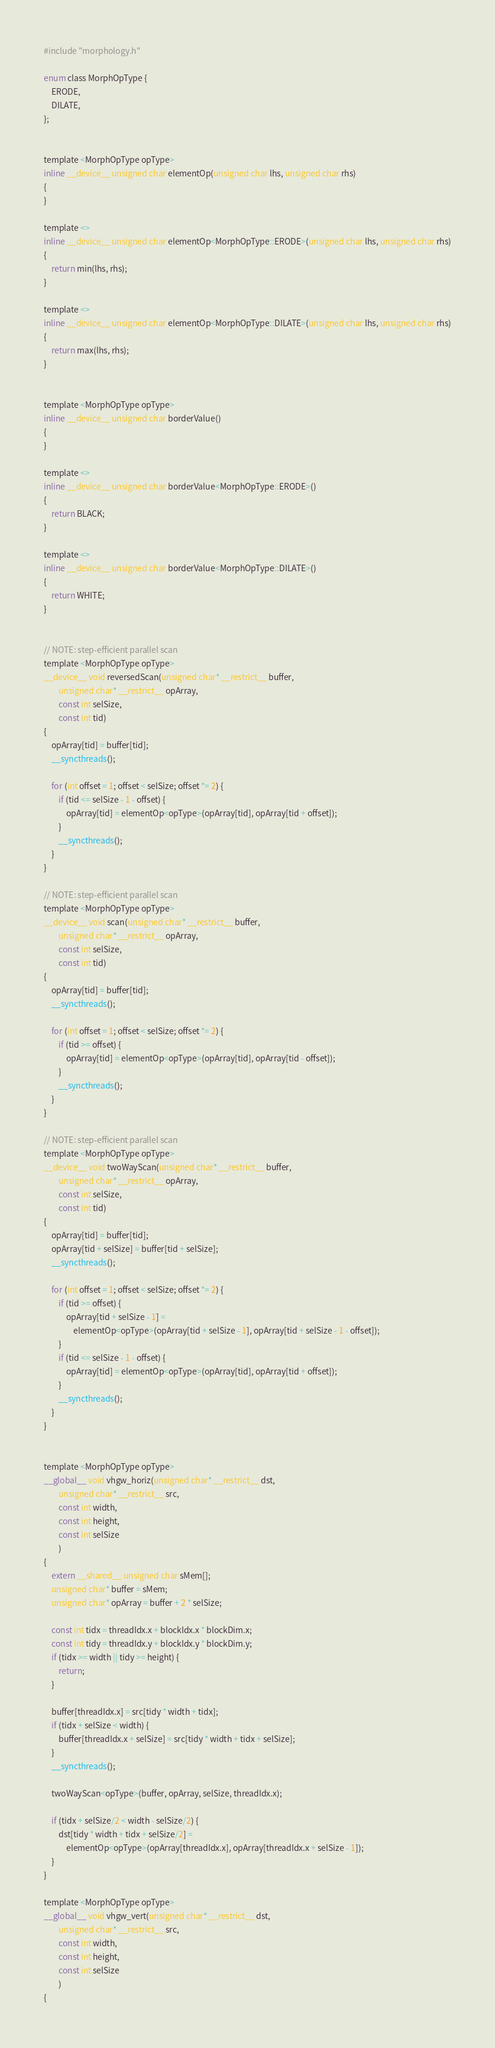<code> <loc_0><loc_0><loc_500><loc_500><_Cuda_>#include "morphology.h"

enum class MorphOpType {
    ERODE,
    DILATE,
};


template <MorphOpType opType>
inline __device__ unsigned char elementOp(unsigned char lhs, unsigned char rhs)
{
}

template <>
inline __device__ unsigned char elementOp<MorphOpType::ERODE>(unsigned char lhs, unsigned char rhs)
{
    return min(lhs, rhs);
}

template <>
inline __device__ unsigned char elementOp<MorphOpType::DILATE>(unsigned char lhs, unsigned char rhs)
{
    return max(lhs, rhs);
}


template <MorphOpType opType>
inline __device__ unsigned char borderValue()
{
}

template <>
inline __device__ unsigned char borderValue<MorphOpType::ERODE>()
{
    return BLACK;
}

template <>
inline __device__ unsigned char borderValue<MorphOpType::DILATE>()
{
    return WHITE;
}


// NOTE: step-efficient parallel scan
template <MorphOpType opType>
__device__ void reversedScan(unsigned char* __restrict__ buffer,
        unsigned char* __restrict__ opArray,
        const int selSize,
        const int tid)
{
    opArray[tid] = buffer[tid];
    __syncthreads();

    for (int offset = 1; offset < selSize; offset *= 2) {
        if (tid <= selSize - 1 - offset) {
            opArray[tid] = elementOp<opType>(opArray[tid], opArray[tid + offset]);
        }
        __syncthreads();
    }
}

// NOTE: step-efficient parallel scan
template <MorphOpType opType>
__device__ void scan(unsigned char* __restrict__ buffer,
        unsigned char* __restrict__ opArray,
        const int selSize,
        const int tid)
{
    opArray[tid] = buffer[tid];
    __syncthreads();

    for (int offset = 1; offset < selSize; offset *= 2) {
        if (tid >= offset) {
            opArray[tid] = elementOp<opType>(opArray[tid], opArray[tid - offset]);
        }
        __syncthreads();
    }
}

// NOTE: step-efficient parallel scan
template <MorphOpType opType>
__device__ void twoWayScan(unsigned char* __restrict__ buffer,
        unsigned char* __restrict__ opArray,
        const int selSize,
        const int tid)
{
    opArray[tid] = buffer[tid];
    opArray[tid + selSize] = buffer[tid + selSize];
    __syncthreads();

    for (int offset = 1; offset < selSize; offset *= 2) {
        if (tid >= offset) {
            opArray[tid + selSize - 1] = 
                elementOp<opType>(opArray[tid + selSize - 1], opArray[tid + selSize - 1 - offset]);
        }
        if (tid <= selSize - 1 - offset) {
            opArray[tid] = elementOp<opType>(opArray[tid], opArray[tid + offset]);
        }
        __syncthreads();
    }
}


template <MorphOpType opType>
__global__ void vhgw_horiz(unsigned char* __restrict__ dst,
        unsigned char* __restrict__ src,
        const int width,
        const int height,
        const int selSize
        )
{
    extern __shared__ unsigned char sMem[];
    unsigned char* buffer = sMem;
    unsigned char* opArray = buffer + 2 * selSize;

    const int tidx = threadIdx.x + blockIdx.x * blockDim.x;
    const int tidy = threadIdx.y + blockIdx.y * blockDim.y;
    if (tidx >= width || tidy >= height) {
        return;
    }

    buffer[threadIdx.x] = src[tidy * width + tidx];
    if (tidx + selSize < width) {
        buffer[threadIdx.x + selSize] = src[tidy * width + tidx + selSize];
    }
    __syncthreads();

    twoWayScan<opType>(buffer, opArray, selSize, threadIdx.x);

    if (tidx + selSize/2 < width - selSize/2) {
        dst[tidy * width + tidx + selSize/2] = 
            elementOp<opType>(opArray[threadIdx.x], opArray[threadIdx.x + selSize - 1]);
    }
}

template <MorphOpType opType>
__global__ void vhgw_vert(unsigned char* __restrict__ dst,
        unsigned char* __restrict__ src,
        const int width,
        const int height,
        const int selSize
        )
{</code> 